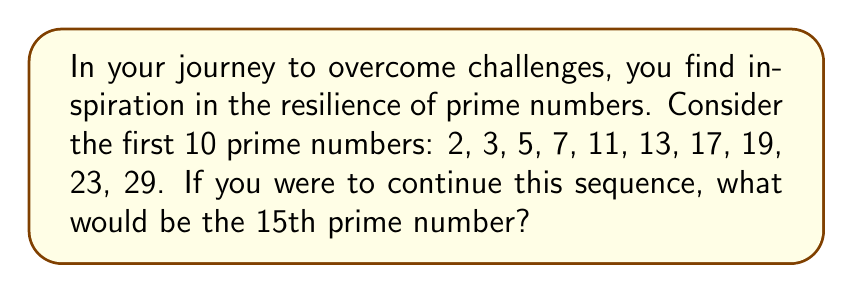Can you answer this question? To find the 15th prime number, we need to continue identifying prime numbers beyond the given list. Let's approach this step-by-step:

1) We already have the first 10 prime numbers. We need to find 5 more.

2) Let's start with the next odd number after 29, which is 31.

3) To check if a number is prime, we need to verify that it's not divisible by any prime number less than or equal to its square root.

4) 31: $\sqrt{31} \approx 5.57$. We only need to check divisibility by 2, 3, and 5.
   31 is not divisible by any of these, so it's prime.
   11th prime: 31

5) 33: Divisible by 3, not prime.

6) 35: Divisible by 5, not prime.

7) 37: $\sqrt{37} \approx 6.08$. Not divisible by 2, 3, or 5.
   12th prime: 37

8) 39: Divisible by 3, not prime.

9) 41: $\sqrt{41} \approx 6.40$. Not divisible by 2, 3, or 5.
   13th prime: 41

10) 43: $\sqrt{43} \approx 6.56$. Not divisible by 2, 3, or 5.
    14th prime: 43

11) 45: Divisible by 3 and 5, not prime.

12) 47: $\sqrt{47} \approx 6.86$. Not divisible by 2, 3, or 5.
    15th prime: 47

Therefore, the 15th prime number is 47.
Answer: 47 